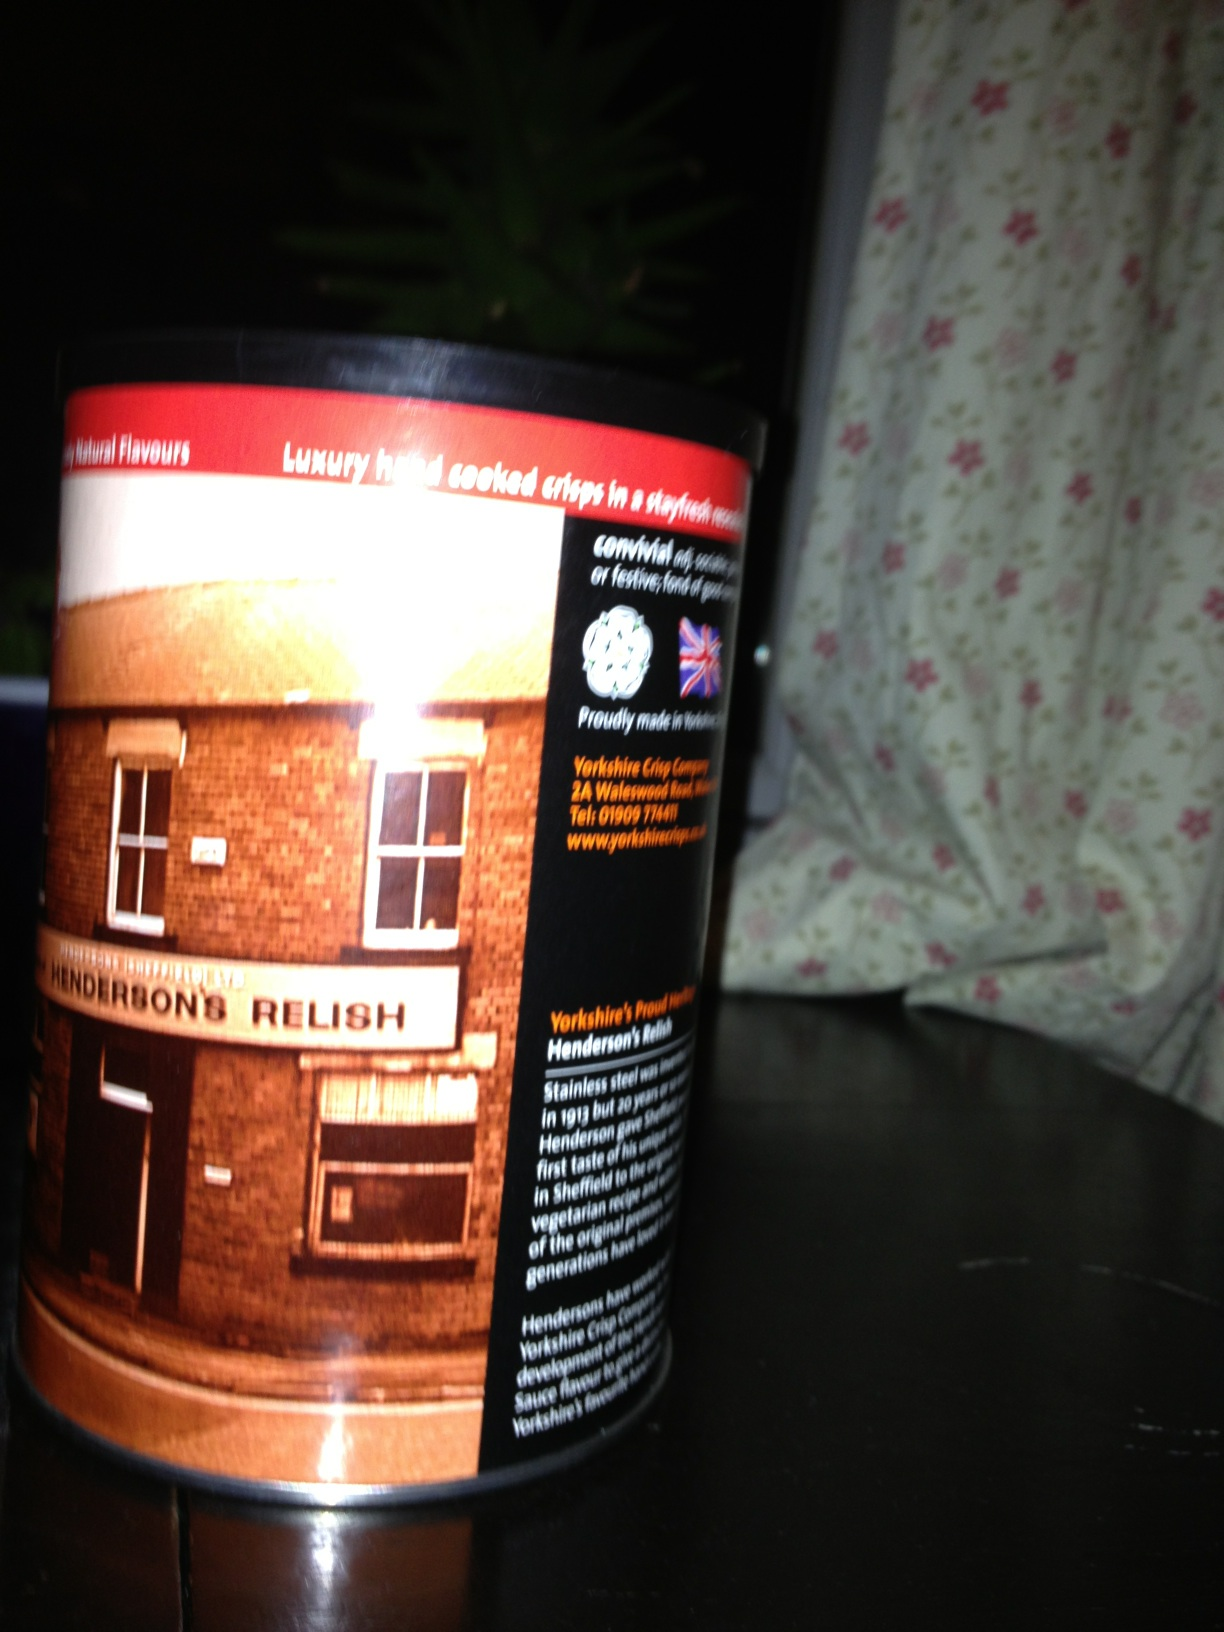Imagine if Henderson's Relish could talk. What story would it tell? If Henderson's Relish could talk, it would tell a tale of humble beginnings at a small factory in Sheffield, England. It would recount the days when its creators first mixed the famed blend of vinegar, tamarind, cayenne pepper, and cloves, concocting a recipe that would stand the test of time. It would share anecdotes of family dinners, famous local eateries, and the many chefs who have poured their creativity into dishes enhanced by its unique flavor. It would boast of its travels beyond the town, becoming a global ambassador of Sheffield's culinary craftsmanship, all the while preserving its enigmatic recipe passed down through generations. 